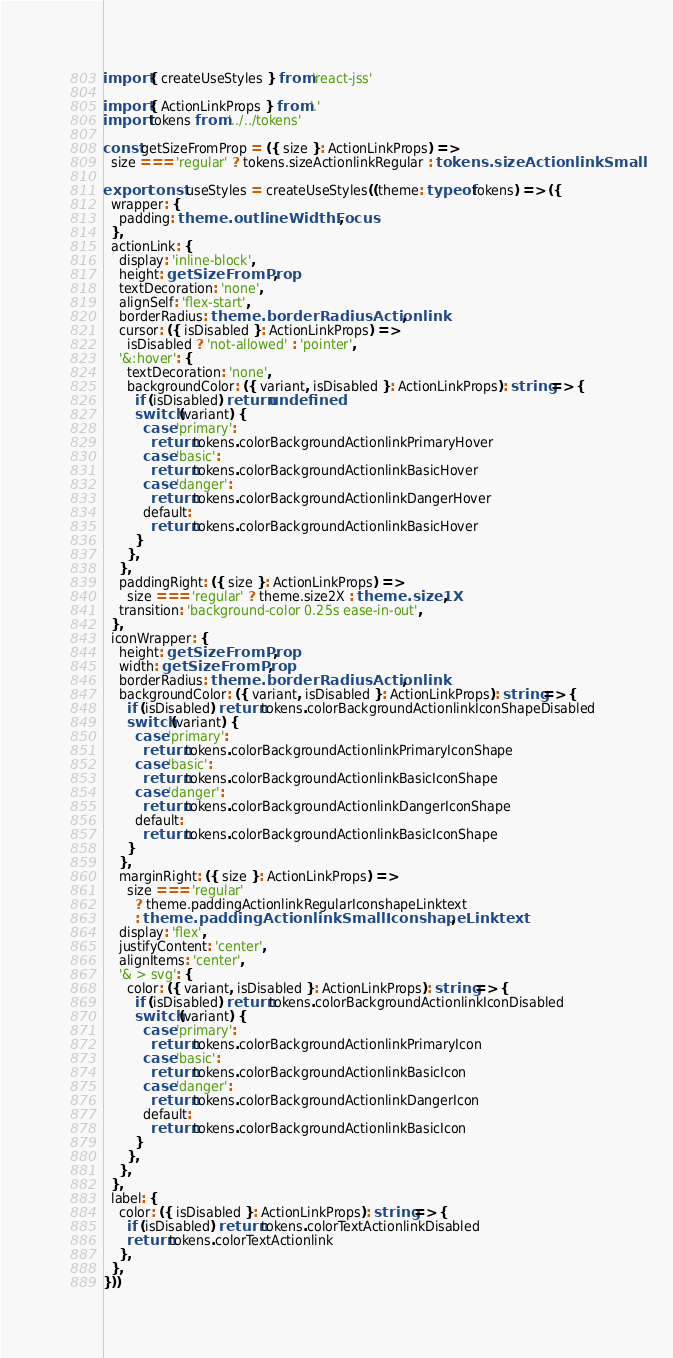<code> <loc_0><loc_0><loc_500><loc_500><_TypeScript_>import { createUseStyles } from 'react-jss'

import { ActionLinkProps } from '.'
import tokens from '../../tokens'

const getSizeFromProp = ({ size }: ActionLinkProps) =>
  size === 'regular' ? tokens.sizeActionlinkRegular : tokens.sizeActionlinkSmall

export const useStyles = createUseStyles((theme: typeof tokens) => ({
  wrapper: {
    padding: theme.outlineWidthFocus,
  },
  actionLink: {
    display: 'inline-block',
    height: getSizeFromProp,
    textDecoration: 'none',
    alignSelf: 'flex-start',
    borderRadius: theme.borderRadiusActionlink,
    cursor: ({ isDisabled }: ActionLinkProps) =>
      isDisabled ? 'not-allowed' : 'pointer',
    '&:hover': {
      textDecoration: 'none',
      backgroundColor: ({ variant, isDisabled }: ActionLinkProps): string => {
        if (isDisabled) return undefined
        switch (variant) {
          case 'primary':
            return tokens.colorBackgroundActionlinkPrimaryHover
          case 'basic':
            return tokens.colorBackgroundActionlinkBasicHover
          case 'danger':
            return tokens.colorBackgroundActionlinkDangerHover
          default:
            return tokens.colorBackgroundActionlinkBasicHover
        }
      },
    },
    paddingRight: ({ size }: ActionLinkProps) =>
      size === 'regular' ? theme.size2X : theme.size1X,
    transition: 'background-color 0.25s ease-in-out',
  },
  iconWrapper: {
    height: getSizeFromProp,
    width: getSizeFromProp,
    borderRadius: theme.borderRadiusActionlink,
    backgroundColor: ({ variant, isDisabled }: ActionLinkProps): string => {
      if (isDisabled) return tokens.colorBackgroundActionlinkIconShapeDisabled
      switch (variant) {
        case 'primary':
          return tokens.colorBackgroundActionlinkPrimaryIconShape
        case 'basic':
          return tokens.colorBackgroundActionlinkBasicIconShape
        case 'danger':
          return tokens.colorBackgroundActionlinkDangerIconShape
        default:
          return tokens.colorBackgroundActionlinkBasicIconShape
      }
    },
    marginRight: ({ size }: ActionLinkProps) =>
      size === 'regular'
        ? theme.paddingActionlinkRegularIconshapeLinktext
        : theme.paddingActionlinkSmallIconshapeLinktext,
    display: 'flex',
    justifyContent: 'center',
    alignItems: 'center',
    '& > svg': {
      color: ({ variant, isDisabled }: ActionLinkProps): string => {
        if (isDisabled) return tokens.colorBackgroundActionlinkIconDisabled
        switch (variant) {
          case 'primary':
            return tokens.colorBackgroundActionlinkPrimaryIcon
          case 'basic':
            return tokens.colorBackgroundActionlinkBasicIcon
          case 'danger':
            return tokens.colorBackgroundActionlinkDangerIcon
          default:
            return tokens.colorBackgroundActionlinkBasicIcon
        }
      },
    },
  },
  label: {
    color: ({ isDisabled }: ActionLinkProps): string => {
      if (isDisabled) return tokens.colorTextActionlinkDisabled
      return tokens.colorTextActionlink
    },
  },
}))
</code> 